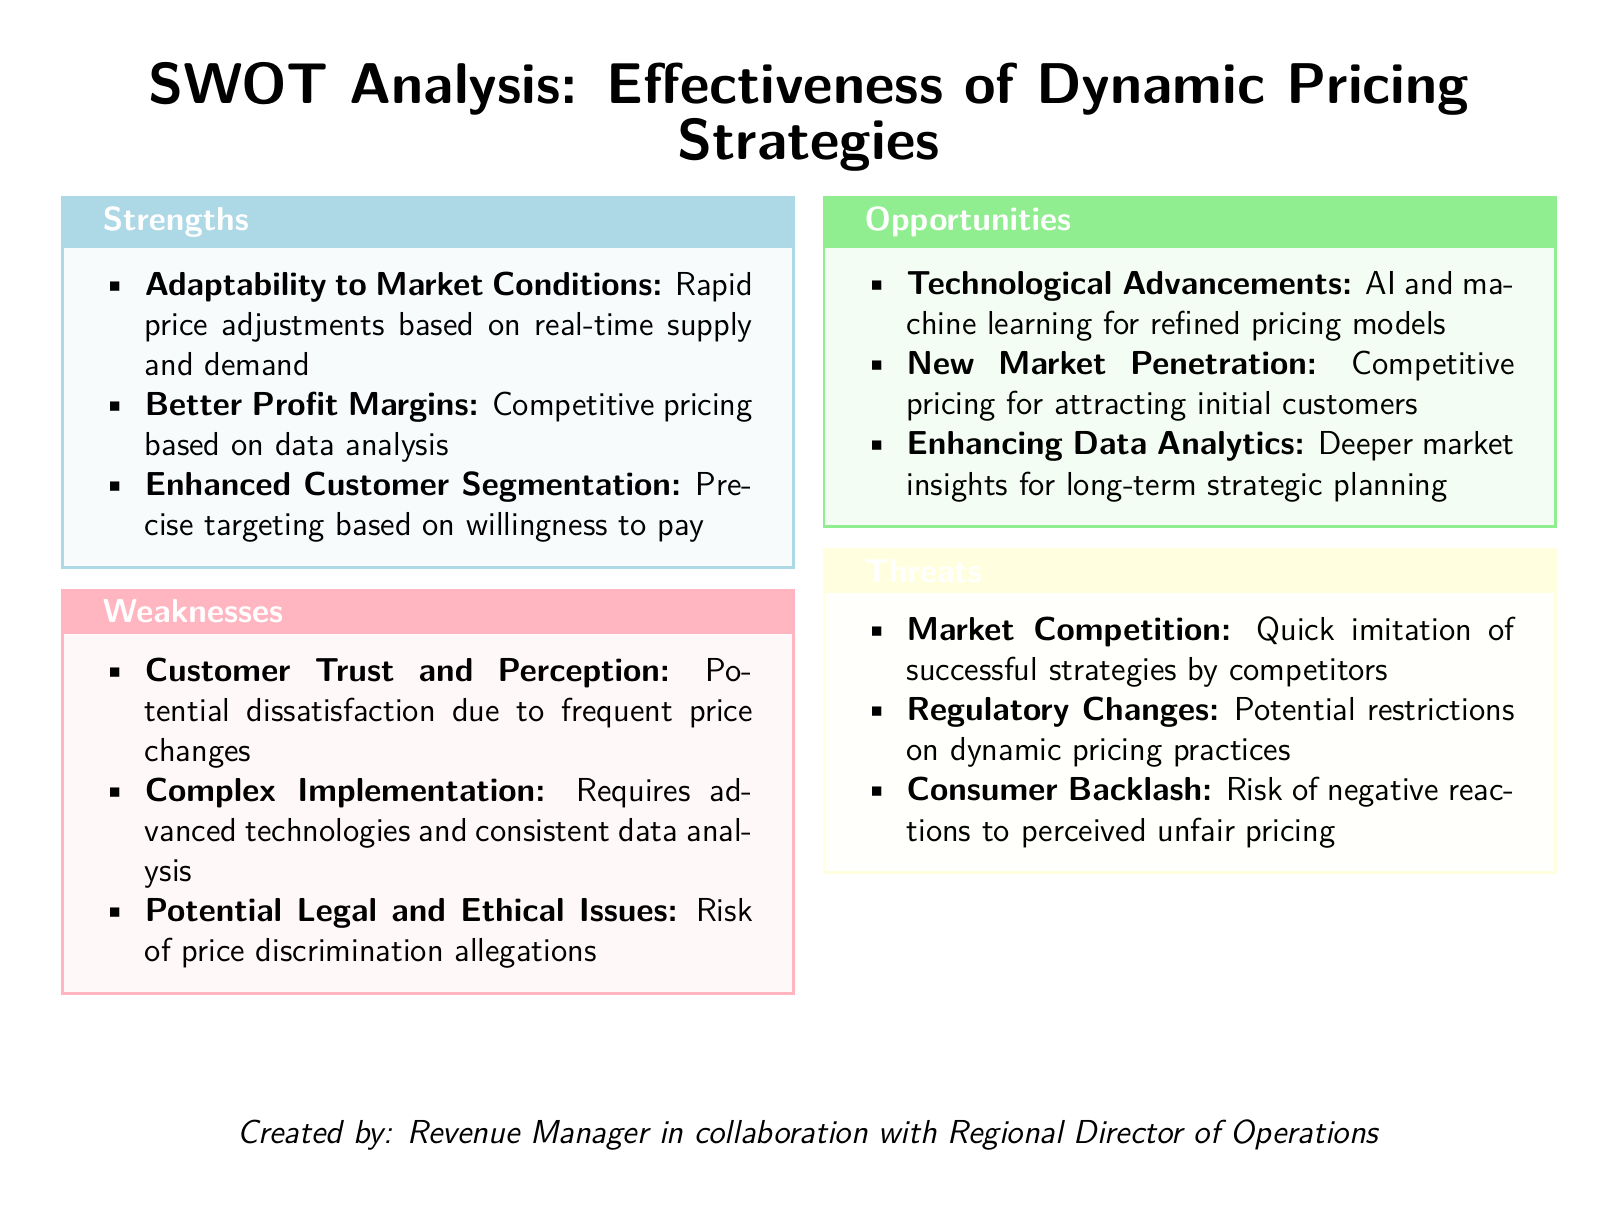what is the title of the document? The title is presented at the top of the document and states the focus of the analysis.
Answer: SWOT Analysis: Effectiveness of Dynamic Pricing Strategies how many strengths are listed? The strengths section contains a specific number of items that can be counted.
Answer: 3 what is a potential weakness related to customer perception? The weaknesses section includes specific issues related to customer trust.
Answer: Potential dissatisfaction due to frequent price changes which opportunity involves technological developments? The opportunities section mentions advancements that can improve pricing strategies.
Answer: AI and machine learning for refined pricing models what threat involves competition? The threats section discusses the competitive landscape impacting dynamic pricing strategies.
Answer: Quick imitation of successful strategies by competitors who collaborated with the revenue manager in creating the document? The document specifies the collaboration in its closing statement.
Answer: Regional Director of Operations 